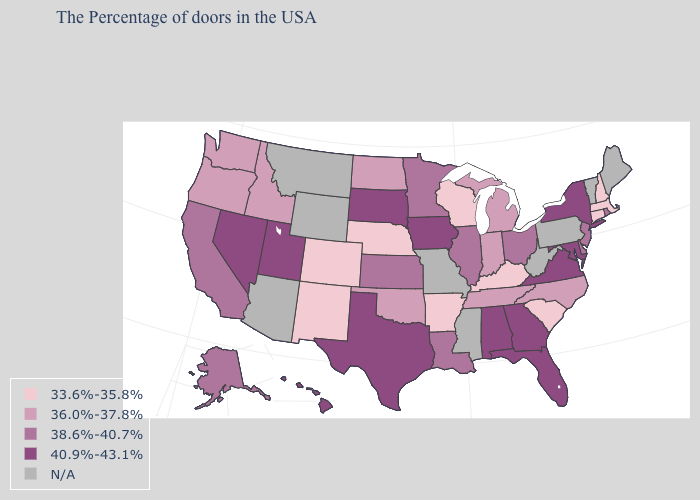Does Kansas have the lowest value in the USA?
Concise answer only. No. What is the value of California?
Write a very short answer. 38.6%-40.7%. Does the first symbol in the legend represent the smallest category?
Write a very short answer. Yes. Is the legend a continuous bar?
Give a very brief answer. No. What is the highest value in states that border Oklahoma?
Give a very brief answer. 40.9%-43.1%. Name the states that have a value in the range 36.0%-37.8%?
Answer briefly. North Carolina, Michigan, Indiana, Tennessee, Oklahoma, North Dakota, Idaho, Washington, Oregon. Name the states that have a value in the range 36.0%-37.8%?
Give a very brief answer. North Carolina, Michigan, Indiana, Tennessee, Oklahoma, North Dakota, Idaho, Washington, Oregon. Name the states that have a value in the range 36.0%-37.8%?
Answer briefly. North Carolina, Michigan, Indiana, Tennessee, Oklahoma, North Dakota, Idaho, Washington, Oregon. Does Minnesota have the highest value in the USA?
Write a very short answer. No. Which states hav the highest value in the MidWest?
Answer briefly. Iowa, South Dakota. Which states have the lowest value in the MidWest?
Quick response, please. Wisconsin, Nebraska. What is the lowest value in states that border Kentucky?
Give a very brief answer. 36.0%-37.8%. Does the first symbol in the legend represent the smallest category?
Be succinct. Yes. How many symbols are there in the legend?
Give a very brief answer. 5. What is the value of Michigan?
Write a very short answer. 36.0%-37.8%. 